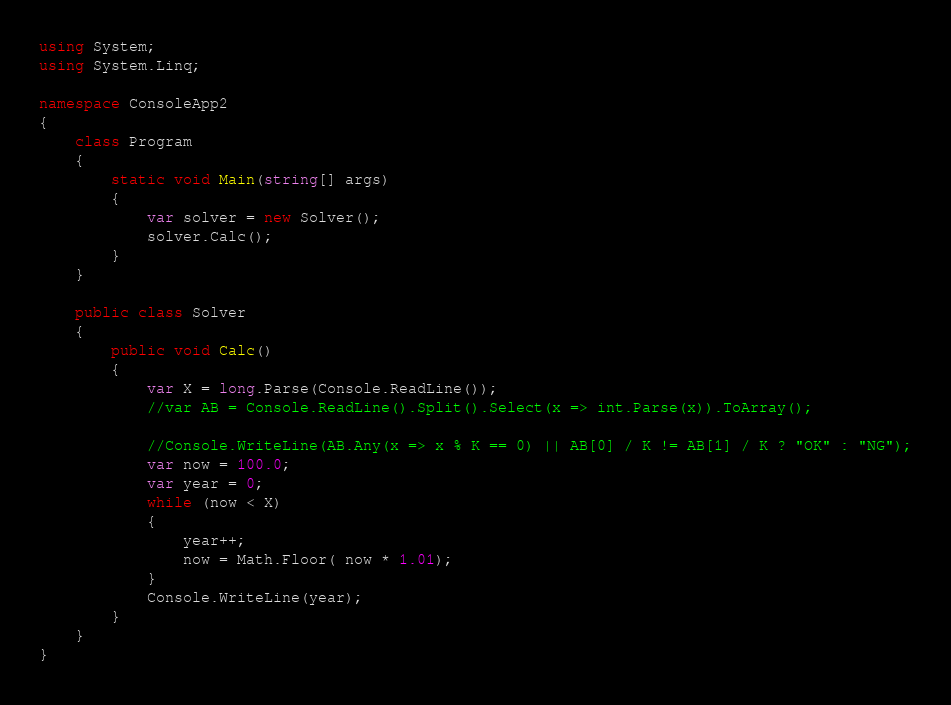Convert code to text. <code><loc_0><loc_0><loc_500><loc_500><_C#_>using System;
using System.Linq;

namespace ConsoleApp2
{
    class Program
    {
        static void Main(string[] args)
        {
            var solver = new Solver();
            solver.Calc();
        }
    }

    public class Solver
    {
        public void Calc()
        {
            var X = long.Parse(Console.ReadLine());
            //var AB = Console.ReadLine().Split().Select(x => int.Parse(x)).ToArray();

            //Console.WriteLine(AB.Any(x => x % K == 0) || AB[0] / K != AB[1] / K ? "OK" : "NG");
            var now = 100.0;
            var year = 0;
            while (now < X)
            {
                year++;
                now = Math.Floor( now * 1.01);
            }
            Console.WriteLine(year);
        }
    }
}
</code> 